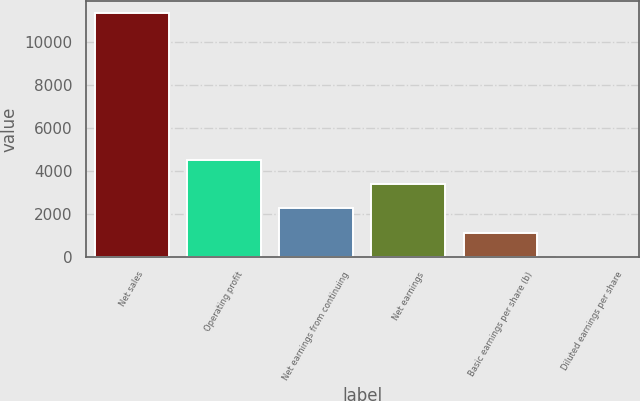Convert chart to OTSL. <chart><loc_0><loc_0><loc_500><loc_500><bar_chart><fcel>Net sales<fcel>Operating profit<fcel>Net earnings from continuing<fcel>Net earnings<fcel>Basic earnings per share (b)<fcel>Diluted earnings per share<nl><fcel>11347<fcel>4540.38<fcel>2271.52<fcel>3405.95<fcel>1137.09<fcel>2.66<nl></chart> 